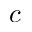Convert formula to latex. <formula><loc_0><loc_0><loc_500><loc_500>c</formula> 